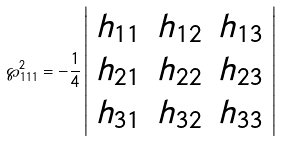Convert formula to latex. <formula><loc_0><loc_0><loc_500><loc_500>\wp _ { 1 1 1 } ^ { 2 } = - \frac { 1 } { 4 } \left | \begin{array} { c c c } h _ { 1 1 } & h _ { 1 2 } & h _ { 1 3 } \\ h _ { 2 1 } & h _ { 2 2 } & h _ { 2 3 } \\ h _ { 3 1 } & h _ { 3 2 } & h _ { 3 3 } \\ \end{array} \right |</formula> 